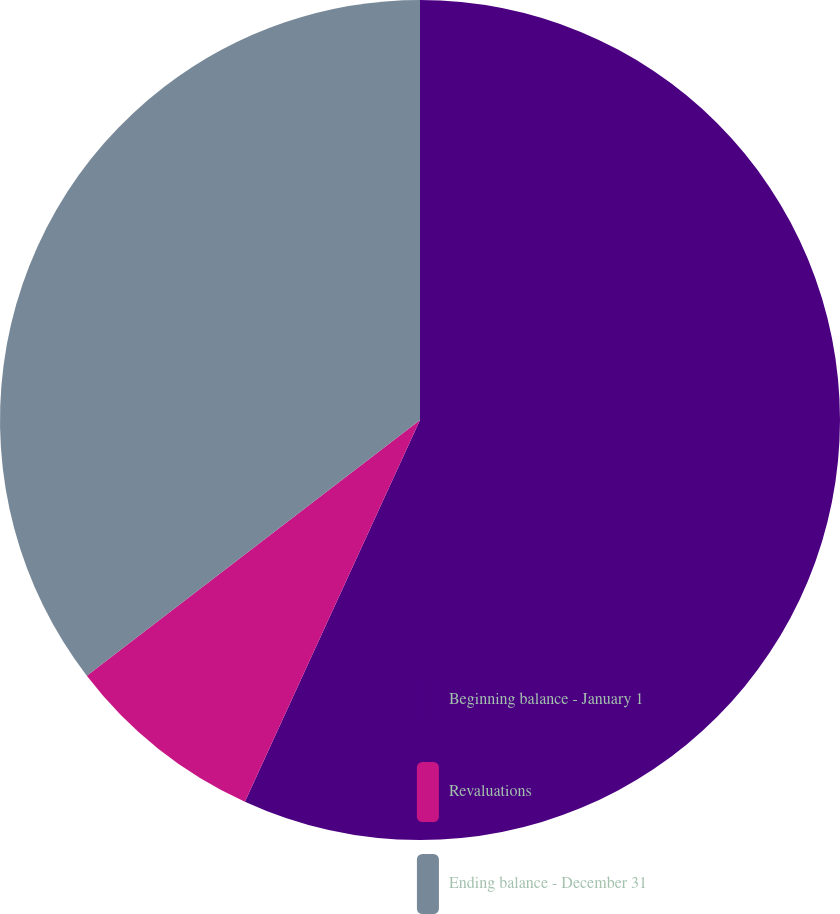Convert chart. <chart><loc_0><loc_0><loc_500><loc_500><pie_chart><fcel>Beginning balance - January 1<fcel>Revaluations<fcel>Ending balance - December 31<nl><fcel>56.85%<fcel>7.74%<fcel>35.42%<nl></chart> 